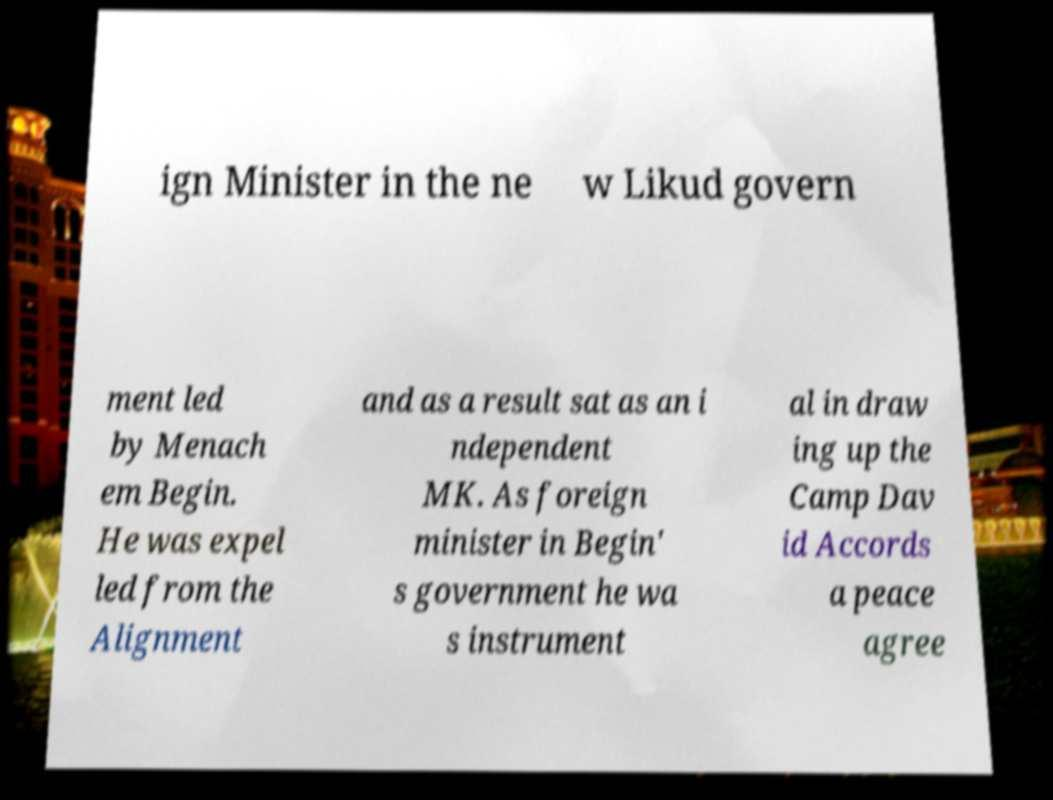Please identify and transcribe the text found in this image. ign Minister in the ne w Likud govern ment led by Menach em Begin. He was expel led from the Alignment and as a result sat as an i ndependent MK. As foreign minister in Begin' s government he wa s instrument al in draw ing up the Camp Dav id Accords a peace agree 